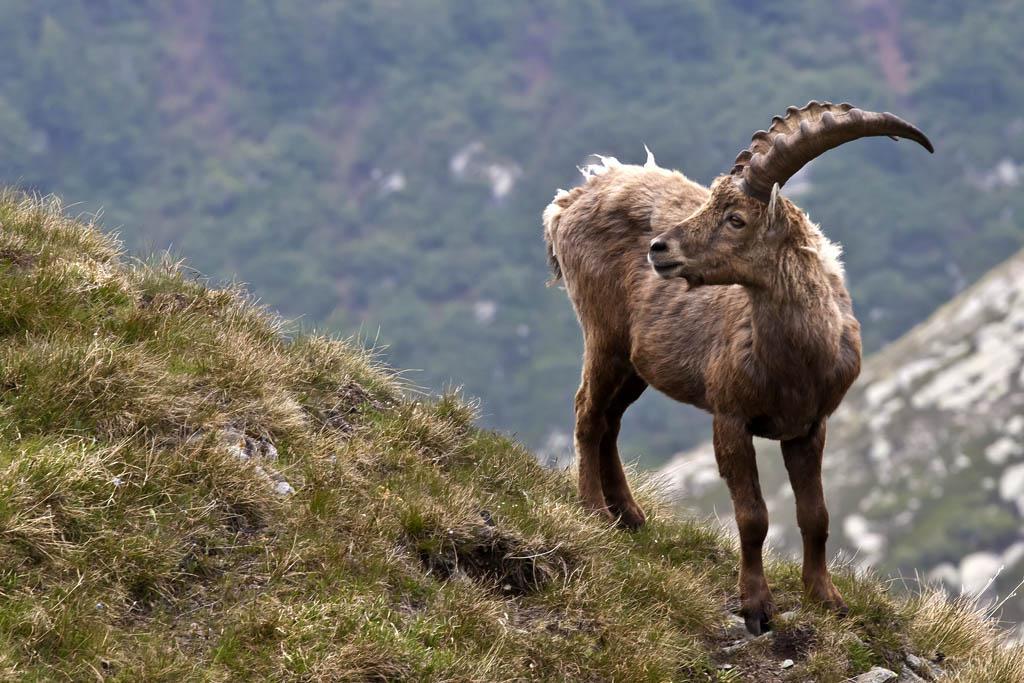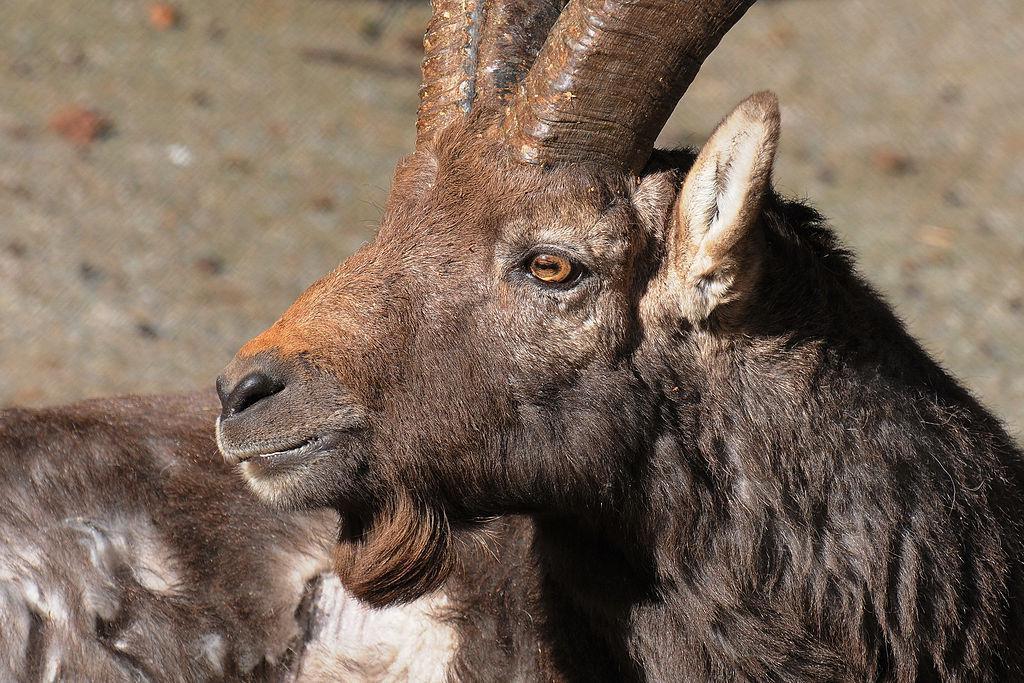The first image is the image on the left, the second image is the image on the right. For the images displayed, is the sentence "Exactly two horned animals are shown in their native habitat." factually correct? Answer yes or no. Yes. The first image is the image on the left, the second image is the image on the right. Evaluate the accuracy of this statement regarding the images: "One image shows two antelope, which are not butting heads.". Is it true? Answer yes or no. No. 